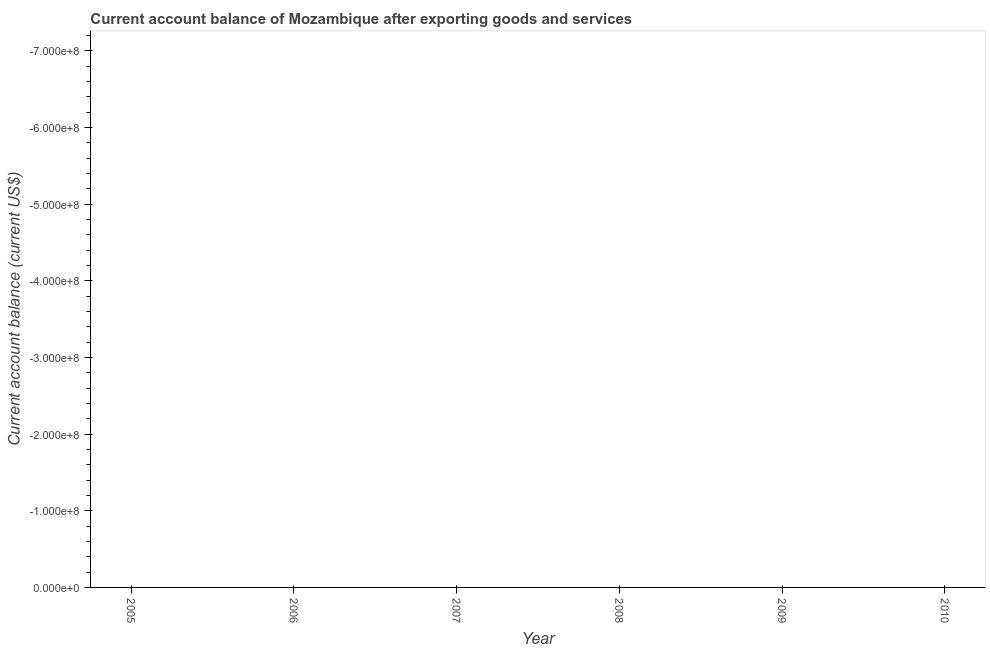What is the current account balance in 2006?
Ensure brevity in your answer.  0. In how many years, is the current account balance greater than -40000000 US$?
Your response must be concise. 0. In how many years, is the current account balance greater than the average current account balance taken over all years?
Your response must be concise. 0. How many lines are there?
Ensure brevity in your answer.  0. How many years are there in the graph?
Your answer should be compact. 6. What is the difference between two consecutive major ticks on the Y-axis?
Keep it short and to the point. 1.00e+08. Are the values on the major ticks of Y-axis written in scientific E-notation?
Provide a short and direct response. Yes. Does the graph contain grids?
Offer a very short reply. No. What is the title of the graph?
Your answer should be very brief. Current account balance of Mozambique after exporting goods and services. What is the label or title of the X-axis?
Provide a succinct answer. Year. What is the label or title of the Y-axis?
Provide a succinct answer. Current account balance (current US$). What is the Current account balance (current US$) in 2005?
Your response must be concise. 0. What is the Current account balance (current US$) in 2006?
Make the answer very short. 0. What is the Current account balance (current US$) of 2007?
Your answer should be very brief. 0. What is the Current account balance (current US$) in 2009?
Your answer should be very brief. 0. 